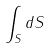<formula> <loc_0><loc_0><loc_500><loc_500>\int _ { S } d S</formula> 